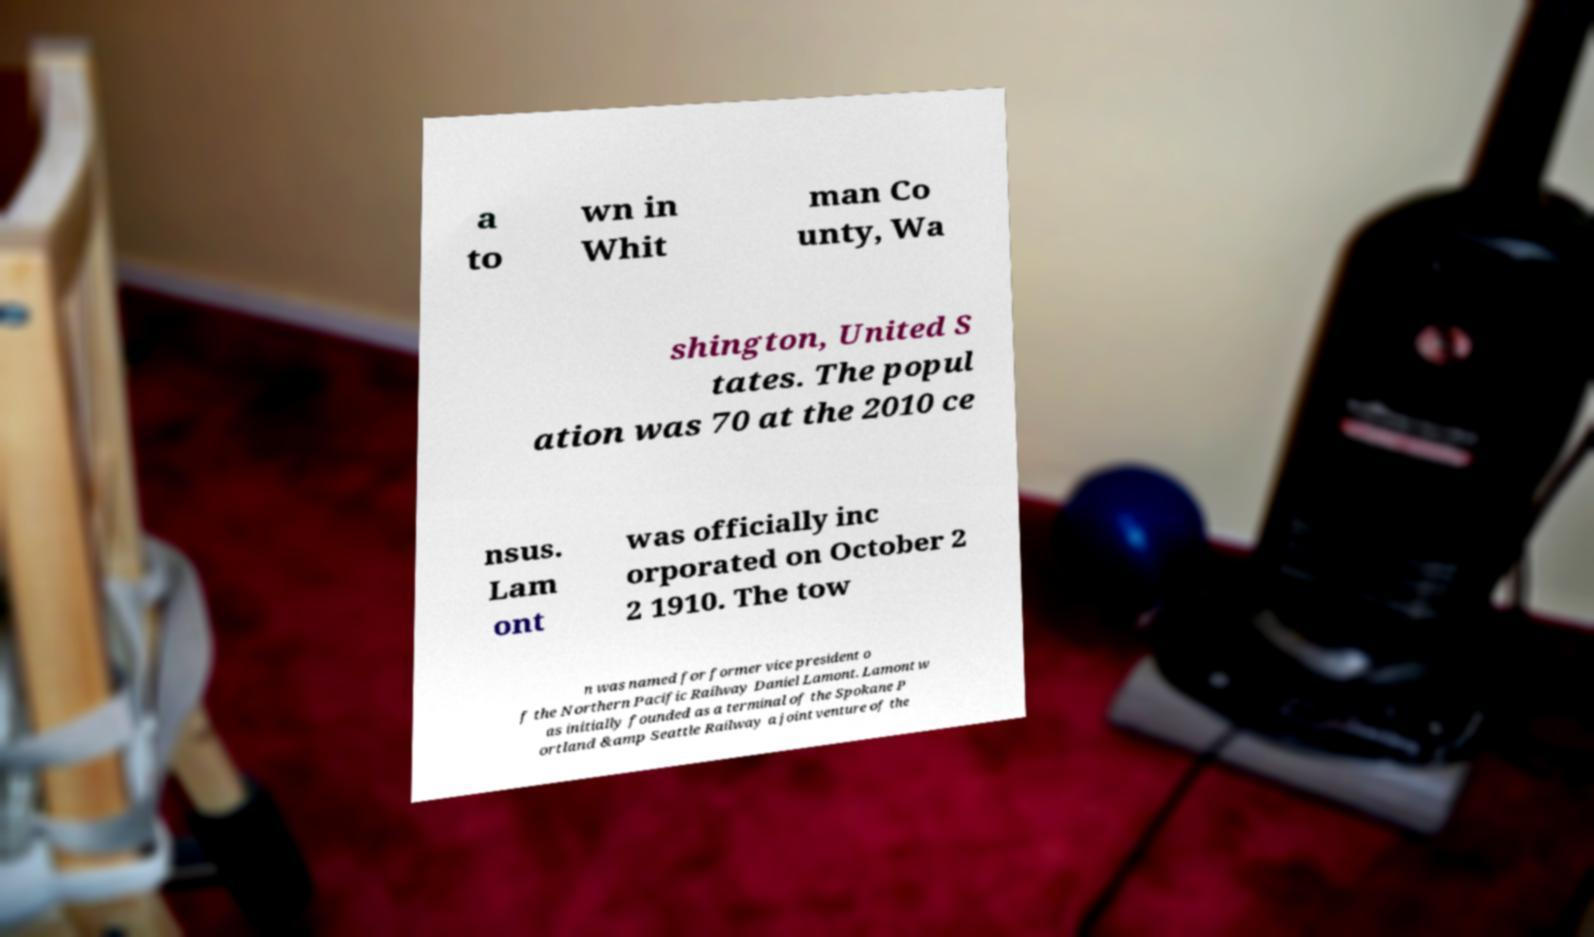There's text embedded in this image that I need extracted. Can you transcribe it verbatim? a to wn in Whit man Co unty, Wa shington, United S tates. The popul ation was 70 at the 2010 ce nsus. Lam ont was officially inc orporated on October 2 2 1910. The tow n was named for former vice president o f the Northern Pacific Railway Daniel Lamont. Lamont w as initially founded as a terminal of the Spokane P ortland &amp Seattle Railway a joint venture of the 